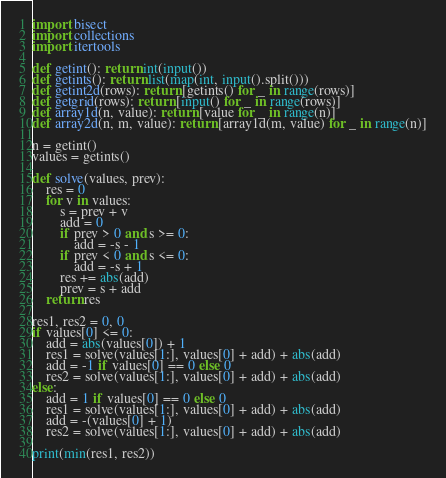Convert code to text. <code><loc_0><loc_0><loc_500><loc_500><_Python_>
import bisect
import collections
import itertools

def getint(): return int(input())
def getints(): return list(map(int, input().split()))
def getint2d(rows): return [getints() for _ in range(rows)]
def getgrid(rows): return [input() for _ in range(rows)]
def array1d(n, value): return [value for _ in range(n)]
def array2d(n, m, value): return [array1d(m, value) for _ in range(n)]

n = getint()
values = getints()

def solve(values, prev):
    res = 0
    for v in values:
        s = prev + v
        add = 0
        if prev > 0 and s >= 0:
            add = -s - 1
        if prev < 0 and s <= 0:
            add = -s + 1
        res += abs(add)
        prev = s + add
    return res

res1, res2 = 0, 0
if values[0] <= 0:
    add = abs(values[0]) + 1
    res1 = solve(values[1:], values[0] + add) + abs(add)
    add = -1 if values[0] == 0 else 0
    res2 = solve(values[1:], values[0] + add) + abs(add)
else:
    add = 1 if values[0] == 0 else 0
    res1 = solve(values[1:], values[0] + add) + abs(add)
    add = -(values[0] + 1)
    res2 = solve(values[1:], values[0] + add) + abs(add)

print(min(res1, res2))
</code> 